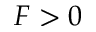Convert formula to latex. <formula><loc_0><loc_0><loc_500><loc_500>F > 0</formula> 